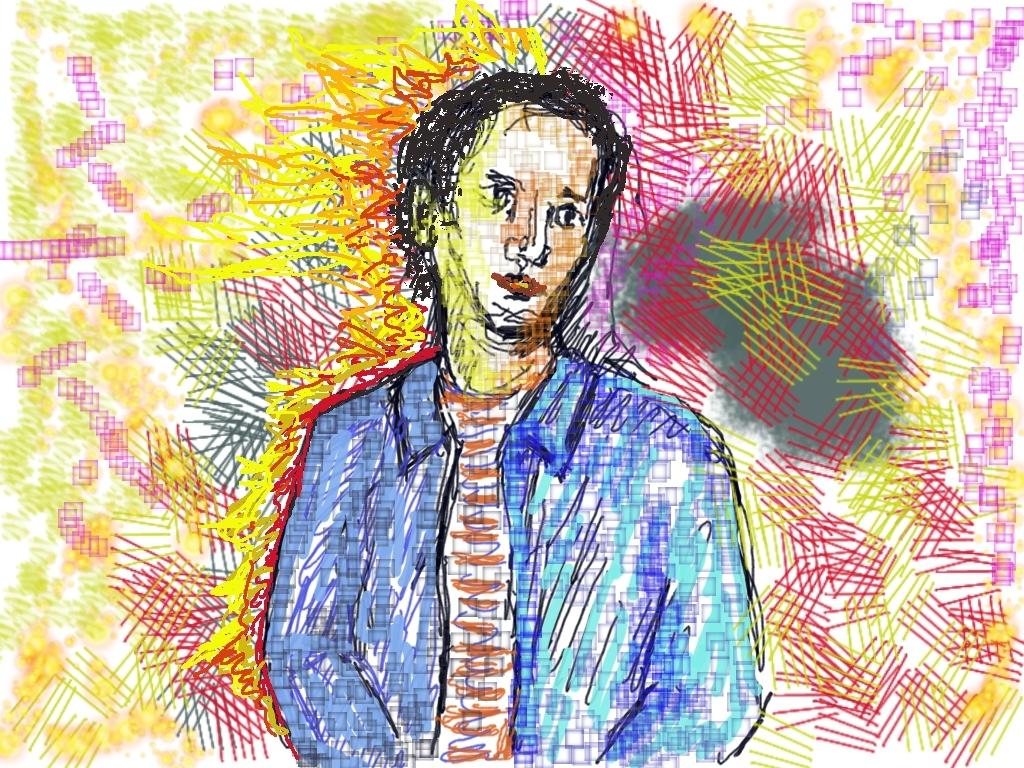What is depicted in the image? The image contains a drawing of a man. What is the man wearing in the drawing? The man is wearing a blue coat. In which direction is the man looking in the drawing? The man is looking to the right side. What type of coal is being used to fuel the man's attempt in the image? There is no coal or attempt present in the image; it is a drawing of a man wearing a blue coat and looking to the right side. 